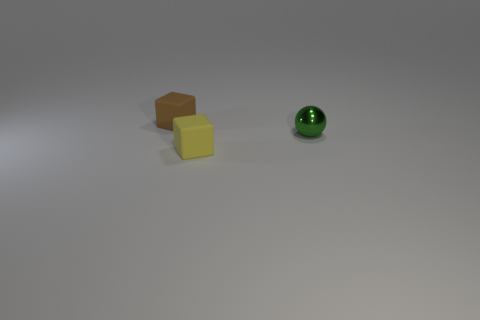Add 1 tiny green matte balls. How many objects exist? 4 Subtract 0 blue balls. How many objects are left? 3 Subtract all spheres. How many objects are left? 2 Subtract all purple balls. Subtract all red blocks. How many balls are left? 1 Subtract all yellow blocks. Subtract all small cubes. How many objects are left? 0 Add 3 yellow rubber things. How many yellow rubber things are left? 4 Add 1 small yellow rubber cubes. How many small yellow rubber cubes exist? 2 